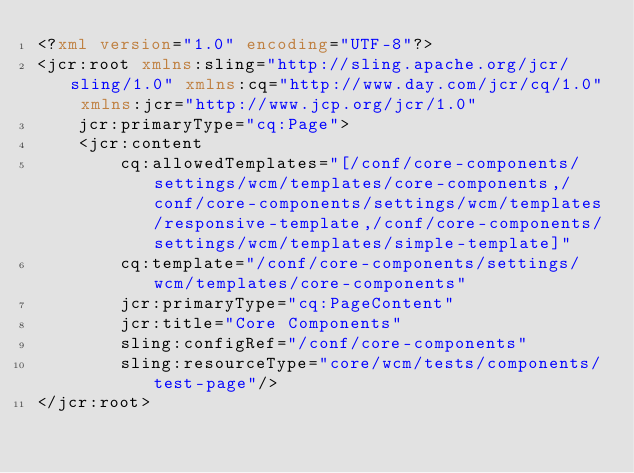Convert code to text. <code><loc_0><loc_0><loc_500><loc_500><_XML_><?xml version="1.0" encoding="UTF-8"?>
<jcr:root xmlns:sling="http://sling.apache.org/jcr/sling/1.0" xmlns:cq="http://www.day.com/jcr/cq/1.0" xmlns:jcr="http://www.jcp.org/jcr/1.0"
    jcr:primaryType="cq:Page">
    <jcr:content
        cq:allowedTemplates="[/conf/core-components/settings/wcm/templates/core-components,/conf/core-components/settings/wcm/templates/responsive-template,/conf/core-components/settings/wcm/templates/simple-template]"
        cq:template="/conf/core-components/settings/wcm/templates/core-components"
        jcr:primaryType="cq:PageContent"
        jcr:title="Core Components"
        sling:configRef="/conf/core-components"
        sling:resourceType="core/wcm/tests/components/test-page"/>
</jcr:root>
</code> 